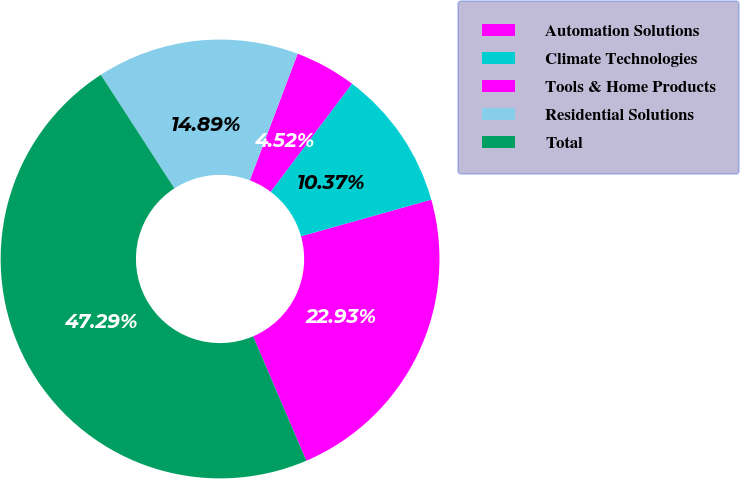<chart> <loc_0><loc_0><loc_500><loc_500><pie_chart><fcel>Automation Solutions<fcel>Climate Technologies<fcel>Tools & Home Products<fcel>Residential Solutions<fcel>Total<nl><fcel>22.93%<fcel>10.37%<fcel>4.52%<fcel>14.89%<fcel>47.29%<nl></chart> 